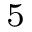<formula> <loc_0><loc_0><loc_500><loc_500>^ { 5 }</formula> 